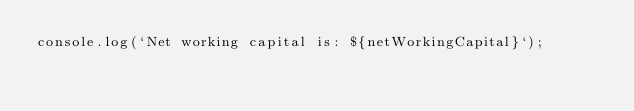<code> <loc_0><loc_0><loc_500><loc_500><_JavaScript_>console.log(`Net working capital is: ${netWorkingCapital}`);</code> 